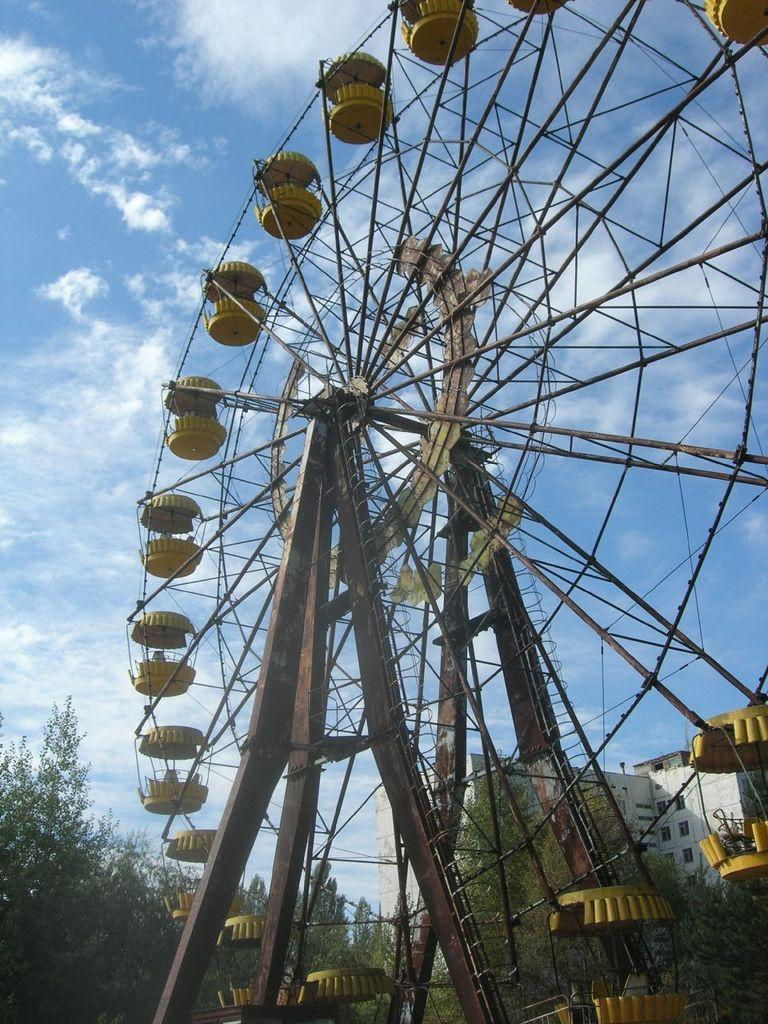What is the main structure in the image? There is a giant wheel in the image. What else can be seen in the image besides the giant wheel? There are rods in the image. What is visible in the background of the image? There is a building, trees, and the sky in the background of the image. What can be observed in the sky? Clouds are present in the sky. How many trucks are connected to the giant wheel in the image? There are no trucks present in the image; it only features a giant wheel and rods. What type of hook is attached to the giant wheel in the image? There is no hook attached to the giant wheel in the image; it only features a giant wheel and rods. 